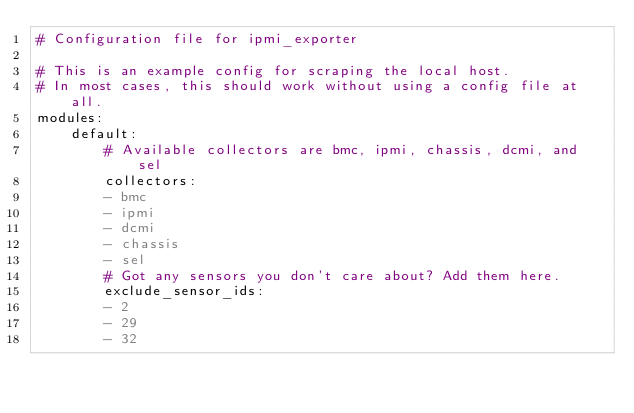<code> <loc_0><loc_0><loc_500><loc_500><_YAML_># Configuration file for ipmi_exporter

# This is an example config for scraping the local host.
# In most cases, this should work without using a config file at all.
modules:
    default:
        # Available collectors are bmc, ipmi, chassis, dcmi, and sel
        collectors:
        - bmc
        - ipmi
        - dcmi
        - chassis
        - sel
        # Got any sensors you don't care about? Add them here.
        exclude_sensor_ids:
        - 2
        - 29
        - 32
</code> 